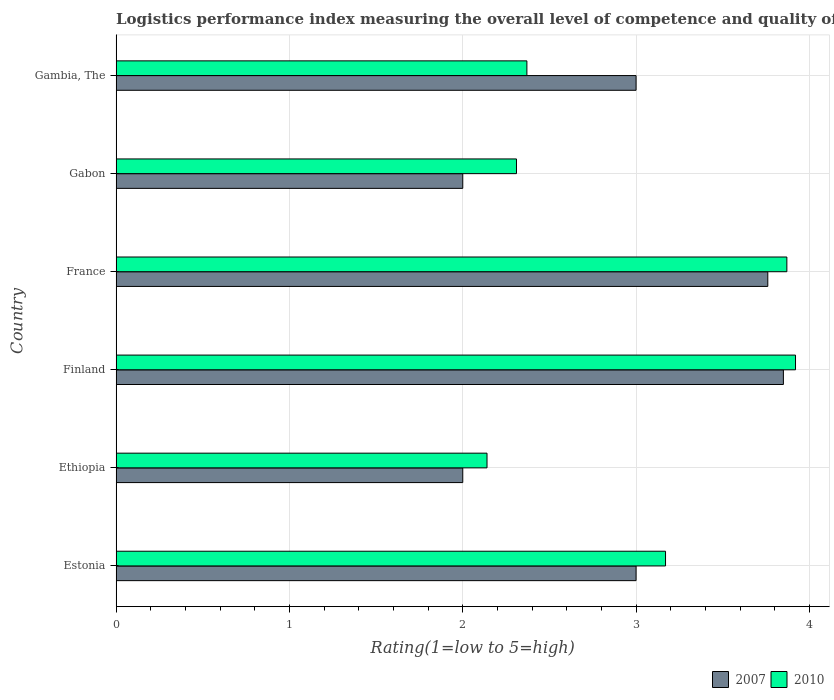How many groups of bars are there?
Give a very brief answer. 6. How many bars are there on the 6th tick from the top?
Your response must be concise. 2. What is the label of the 5th group of bars from the top?
Offer a very short reply. Ethiopia. What is the Logistic performance index in 2007 in Finland?
Your response must be concise. 3.85. Across all countries, what is the maximum Logistic performance index in 2010?
Give a very brief answer. 3.92. Across all countries, what is the minimum Logistic performance index in 2010?
Keep it short and to the point. 2.14. In which country was the Logistic performance index in 2007 minimum?
Your response must be concise. Ethiopia. What is the total Logistic performance index in 2007 in the graph?
Make the answer very short. 17.61. What is the difference between the Logistic performance index in 2007 in France and that in Gabon?
Provide a succinct answer. 1.76. What is the difference between the Logistic performance index in 2007 in Estonia and the Logistic performance index in 2010 in Gabon?
Your answer should be compact. 0.69. What is the average Logistic performance index in 2007 per country?
Offer a terse response. 2.94. What is the difference between the Logistic performance index in 2007 and Logistic performance index in 2010 in Estonia?
Offer a terse response. -0.17. In how many countries, is the Logistic performance index in 2010 greater than 1 ?
Give a very brief answer. 6. What is the ratio of the Logistic performance index in 2010 in Ethiopia to that in France?
Your answer should be very brief. 0.55. What is the difference between the highest and the second highest Logistic performance index in 2007?
Provide a short and direct response. 0.09. What is the difference between the highest and the lowest Logistic performance index in 2007?
Your response must be concise. 1.85. In how many countries, is the Logistic performance index in 2007 greater than the average Logistic performance index in 2007 taken over all countries?
Offer a terse response. 4. Is the sum of the Logistic performance index in 2010 in Estonia and Gambia, The greater than the maximum Logistic performance index in 2007 across all countries?
Give a very brief answer. Yes. What does the 2nd bar from the top in Estonia represents?
Give a very brief answer. 2007. What does the 1st bar from the bottom in Estonia represents?
Ensure brevity in your answer.  2007. How many bars are there?
Your answer should be compact. 12. Are all the bars in the graph horizontal?
Ensure brevity in your answer.  Yes. How many countries are there in the graph?
Keep it short and to the point. 6. What is the title of the graph?
Offer a very short reply. Logistics performance index measuring the overall level of competence and quality of logistics services. What is the label or title of the X-axis?
Ensure brevity in your answer.  Rating(1=low to 5=high). What is the Rating(1=low to 5=high) in 2010 in Estonia?
Your answer should be very brief. 3.17. What is the Rating(1=low to 5=high) of 2010 in Ethiopia?
Provide a short and direct response. 2.14. What is the Rating(1=low to 5=high) in 2007 in Finland?
Make the answer very short. 3.85. What is the Rating(1=low to 5=high) in 2010 in Finland?
Offer a very short reply. 3.92. What is the Rating(1=low to 5=high) in 2007 in France?
Make the answer very short. 3.76. What is the Rating(1=low to 5=high) in 2010 in France?
Your answer should be very brief. 3.87. What is the Rating(1=low to 5=high) of 2007 in Gabon?
Give a very brief answer. 2. What is the Rating(1=low to 5=high) in 2010 in Gabon?
Ensure brevity in your answer.  2.31. What is the Rating(1=low to 5=high) in 2007 in Gambia, The?
Offer a terse response. 3. What is the Rating(1=low to 5=high) of 2010 in Gambia, The?
Your answer should be compact. 2.37. Across all countries, what is the maximum Rating(1=low to 5=high) in 2007?
Make the answer very short. 3.85. Across all countries, what is the maximum Rating(1=low to 5=high) in 2010?
Provide a short and direct response. 3.92. Across all countries, what is the minimum Rating(1=low to 5=high) in 2010?
Give a very brief answer. 2.14. What is the total Rating(1=low to 5=high) in 2007 in the graph?
Offer a terse response. 17.61. What is the total Rating(1=low to 5=high) in 2010 in the graph?
Ensure brevity in your answer.  17.78. What is the difference between the Rating(1=low to 5=high) in 2007 in Estonia and that in Ethiopia?
Provide a short and direct response. 1. What is the difference between the Rating(1=low to 5=high) in 2007 in Estonia and that in Finland?
Your answer should be very brief. -0.85. What is the difference between the Rating(1=low to 5=high) of 2010 in Estonia and that in Finland?
Your response must be concise. -0.75. What is the difference between the Rating(1=low to 5=high) of 2007 in Estonia and that in France?
Give a very brief answer. -0.76. What is the difference between the Rating(1=low to 5=high) in 2010 in Estonia and that in France?
Provide a succinct answer. -0.7. What is the difference between the Rating(1=low to 5=high) in 2007 in Estonia and that in Gabon?
Give a very brief answer. 1. What is the difference between the Rating(1=low to 5=high) of 2010 in Estonia and that in Gabon?
Your answer should be very brief. 0.86. What is the difference between the Rating(1=low to 5=high) of 2007 in Estonia and that in Gambia, The?
Offer a terse response. 0. What is the difference between the Rating(1=low to 5=high) in 2007 in Ethiopia and that in Finland?
Ensure brevity in your answer.  -1.85. What is the difference between the Rating(1=low to 5=high) in 2010 in Ethiopia and that in Finland?
Offer a very short reply. -1.78. What is the difference between the Rating(1=low to 5=high) in 2007 in Ethiopia and that in France?
Provide a short and direct response. -1.76. What is the difference between the Rating(1=low to 5=high) in 2010 in Ethiopia and that in France?
Give a very brief answer. -1.73. What is the difference between the Rating(1=low to 5=high) in 2010 in Ethiopia and that in Gabon?
Your response must be concise. -0.17. What is the difference between the Rating(1=low to 5=high) in 2007 in Ethiopia and that in Gambia, The?
Your answer should be compact. -1. What is the difference between the Rating(1=low to 5=high) of 2010 in Ethiopia and that in Gambia, The?
Provide a succinct answer. -0.23. What is the difference between the Rating(1=low to 5=high) in 2007 in Finland and that in France?
Provide a short and direct response. 0.09. What is the difference between the Rating(1=low to 5=high) of 2010 in Finland and that in France?
Make the answer very short. 0.05. What is the difference between the Rating(1=low to 5=high) in 2007 in Finland and that in Gabon?
Your answer should be very brief. 1.85. What is the difference between the Rating(1=low to 5=high) of 2010 in Finland and that in Gabon?
Your response must be concise. 1.61. What is the difference between the Rating(1=low to 5=high) of 2010 in Finland and that in Gambia, The?
Your answer should be very brief. 1.55. What is the difference between the Rating(1=low to 5=high) of 2007 in France and that in Gabon?
Make the answer very short. 1.76. What is the difference between the Rating(1=low to 5=high) in 2010 in France and that in Gabon?
Your response must be concise. 1.56. What is the difference between the Rating(1=low to 5=high) of 2007 in France and that in Gambia, The?
Offer a terse response. 0.76. What is the difference between the Rating(1=low to 5=high) of 2007 in Gabon and that in Gambia, The?
Ensure brevity in your answer.  -1. What is the difference between the Rating(1=low to 5=high) in 2010 in Gabon and that in Gambia, The?
Ensure brevity in your answer.  -0.06. What is the difference between the Rating(1=low to 5=high) in 2007 in Estonia and the Rating(1=low to 5=high) in 2010 in Ethiopia?
Make the answer very short. 0.86. What is the difference between the Rating(1=low to 5=high) of 2007 in Estonia and the Rating(1=low to 5=high) of 2010 in Finland?
Provide a short and direct response. -0.92. What is the difference between the Rating(1=low to 5=high) in 2007 in Estonia and the Rating(1=low to 5=high) in 2010 in France?
Your answer should be very brief. -0.87. What is the difference between the Rating(1=low to 5=high) in 2007 in Estonia and the Rating(1=low to 5=high) in 2010 in Gabon?
Provide a short and direct response. 0.69. What is the difference between the Rating(1=low to 5=high) in 2007 in Estonia and the Rating(1=low to 5=high) in 2010 in Gambia, The?
Provide a short and direct response. 0.63. What is the difference between the Rating(1=low to 5=high) of 2007 in Ethiopia and the Rating(1=low to 5=high) of 2010 in Finland?
Offer a very short reply. -1.92. What is the difference between the Rating(1=low to 5=high) in 2007 in Ethiopia and the Rating(1=low to 5=high) in 2010 in France?
Provide a succinct answer. -1.87. What is the difference between the Rating(1=low to 5=high) in 2007 in Ethiopia and the Rating(1=low to 5=high) in 2010 in Gabon?
Offer a very short reply. -0.31. What is the difference between the Rating(1=low to 5=high) in 2007 in Ethiopia and the Rating(1=low to 5=high) in 2010 in Gambia, The?
Offer a terse response. -0.37. What is the difference between the Rating(1=low to 5=high) in 2007 in Finland and the Rating(1=low to 5=high) in 2010 in France?
Your answer should be compact. -0.02. What is the difference between the Rating(1=low to 5=high) of 2007 in Finland and the Rating(1=low to 5=high) of 2010 in Gabon?
Your answer should be very brief. 1.54. What is the difference between the Rating(1=low to 5=high) of 2007 in Finland and the Rating(1=low to 5=high) of 2010 in Gambia, The?
Your response must be concise. 1.48. What is the difference between the Rating(1=low to 5=high) in 2007 in France and the Rating(1=low to 5=high) in 2010 in Gabon?
Your response must be concise. 1.45. What is the difference between the Rating(1=low to 5=high) of 2007 in France and the Rating(1=low to 5=high) of 2010 in Gambia, The?
Ensure brevity in your answer.  1.39. What is the difference between the Rating(1=low to 5=high) in 2007 in Gabon and the Rating(1=low to 5=high) in 2010 in Gambia, The?
Offer a very short reply. -0.37. What is the average Rating(1=low to 5=high) in 2007 per country?
Provide a short and direct response. 2.94. What is the average Rating(1=low to 5=high) of 2010 per country?
Your response must be concise. 2.96. What is the difference between the Rating(1=low to 5=high) of 2007 and Rating(1=low to 5=high) of 2010 in Estonia?
Offer a very short reply. -0.17. What is the difference between the Rating(1=low to 5=high) of 2007 and Rating(1=low to 5=high) of 2010 in Ethiopia?
Provide a short and direct response. -0.14. What is the difference between the Rating(1=low to 5=high) in 2007 and Rating(1=low to 5=high) in 2010 in Finland?
Ensure brevity in your answer.  -0.07. What is the difference between the Rating(1=low to 5=high) of 2007 and Rating(1=low to 5=high) of 2010 in France?
Give a very brief answer. -0.11. What is the difference between the Rating(1=low to 5=high) of 2007 and Rating(1=low to 5=high) of 2010 in Gabon?
Provide a short and direct response. -0.31. What is the difference between the Rating(1=low to 5=high) in 2007 and Rating(1=low to 5=high) in 2010 in Gambia, The?
Ensure brevity in your answer.  0.63. What is the ratio of the Rating(1=low to 5=high) of 2010 in Estonia to that in Ethiopia?
Offer a terse response. 1.48. What is the ratio of the Rating(1=low to 5=high) of 2007 in Estonia to that in Finland?
Your answer should be compact. 0.78. What is the ratio of the Rating(1=low to 5=high) of 2010 in Estonia to that in Finland?
Offer a terse response. 0.81. What is the ratio of the Rating(1=low to 5=high) of 2007 in Estonia to that in France?
Make the answer very short. 0.8. What is the ratio of the Rating(1=low to 5=high) in 2010 in Estonia to that in France?
Your answer should be compact. 0.82. What is the ratio of the Rating(1=low to 5=high) in 2010 in Estonia to that in Gabon?
Offer a terse response. 1.37. What is the ratio of the Rating(1=low to 5=high) of 2010 in Estonia to that in Gambia, The?
Make the answer very short. 1.34. What is the ratio of the Rating(1=low to 5=high) of 2007 in Ethiopia to that in Finland?
Your response must be concise. 0.52. What is the ratio of the Rating(1=low to 5=high) in 2010 in Ethiopia to that in Finland?
Your response must be concise. 0.55. What is the ratio of the Rating(1=low to 5=high) in 2007 in Ethiopia to that in France?
Provide a succinct answer. 0.53. What is the ratio of the Rating(1=low to 5=high) of 2010 in Ethiopia to that in France?
Your answer should be very brief. 0.55. What is the ratio of the Rating(1=low to 5=high) in 2010 in Ethiopia to that in Gabon?
Your answer should be compact. 0.93. What is the ratio of the Rating(1=low to 5=high) in 2007 in Ethiopia to that in Gambia, The?
Provide a succinct answer. 0.67. What is the ratio of the Rating(1=low to 5=high) of 2010 in Ethiopia to that in Gambia, The?
Your answer should be compact. 0.9. What is the ratio of the Rating(1=low to 5=high) of 2007 in Finland to that in France?
Give a very brief answer. 1.02. What is the ratio of the Rating(1=low to 5=high) of 2010 in Finland to that in France?
Make the answer very short. 1.01. What is the ratio of the Rating(1=low to 5=high) in 2007 in Finland to that in Gabon?
Offer a very short reply. 1.93. What is the ratio of the Rating(1=low to 5=high) in 2010 in Finland to that in Gabon?
Offer a terse response. 1.7. What is the ratio of the Rating(1=low to 5=high) in 2007 in Finland to that in Gambia, The?
Offer a very short reply. 1.28. What is the ratio of the Rating(1=low to 5=high) of 2010 in Finland to that in Gambia, The?
Provide a succinct answer. 1.65. What is the ratio of the Rating(1=low to 5=high) in 2007 in France to that in Gabon?
Make the answer very short. 1.88. What is the ratio of the Rating(1=low to 5=high) of 2010 in France to that in Gabon?
Your answer should be very brief. 1.68. What is the ratio of the Rating(1=low to 5=high) of 2007 in France to that in Gambia, The?
Your answer should be compact. 1.25. What is the ratio of the Rating(1=low to 5=high) in 2010 in France to that in Gambia, The?
Offer a terse response. 1.63. What is the ratio of the Rating(1=low to 5=high) of 2010 in Gabon to that in Gambia, The?
Offer a very short reply. 0.97. What is the difference between the highest and the second highest Rating(1=low to 5=high) of 2007?
Provide a succinct answer. 0.09. What is the difference between the highest and the lowest Rating(1=low to 5=high) in 2007?
Give a very brief answer. 1.85. What is the difference between the highest and the lowest Rating(1=low to 5=high) of 2010?
Your response must be concise. 1.78. 